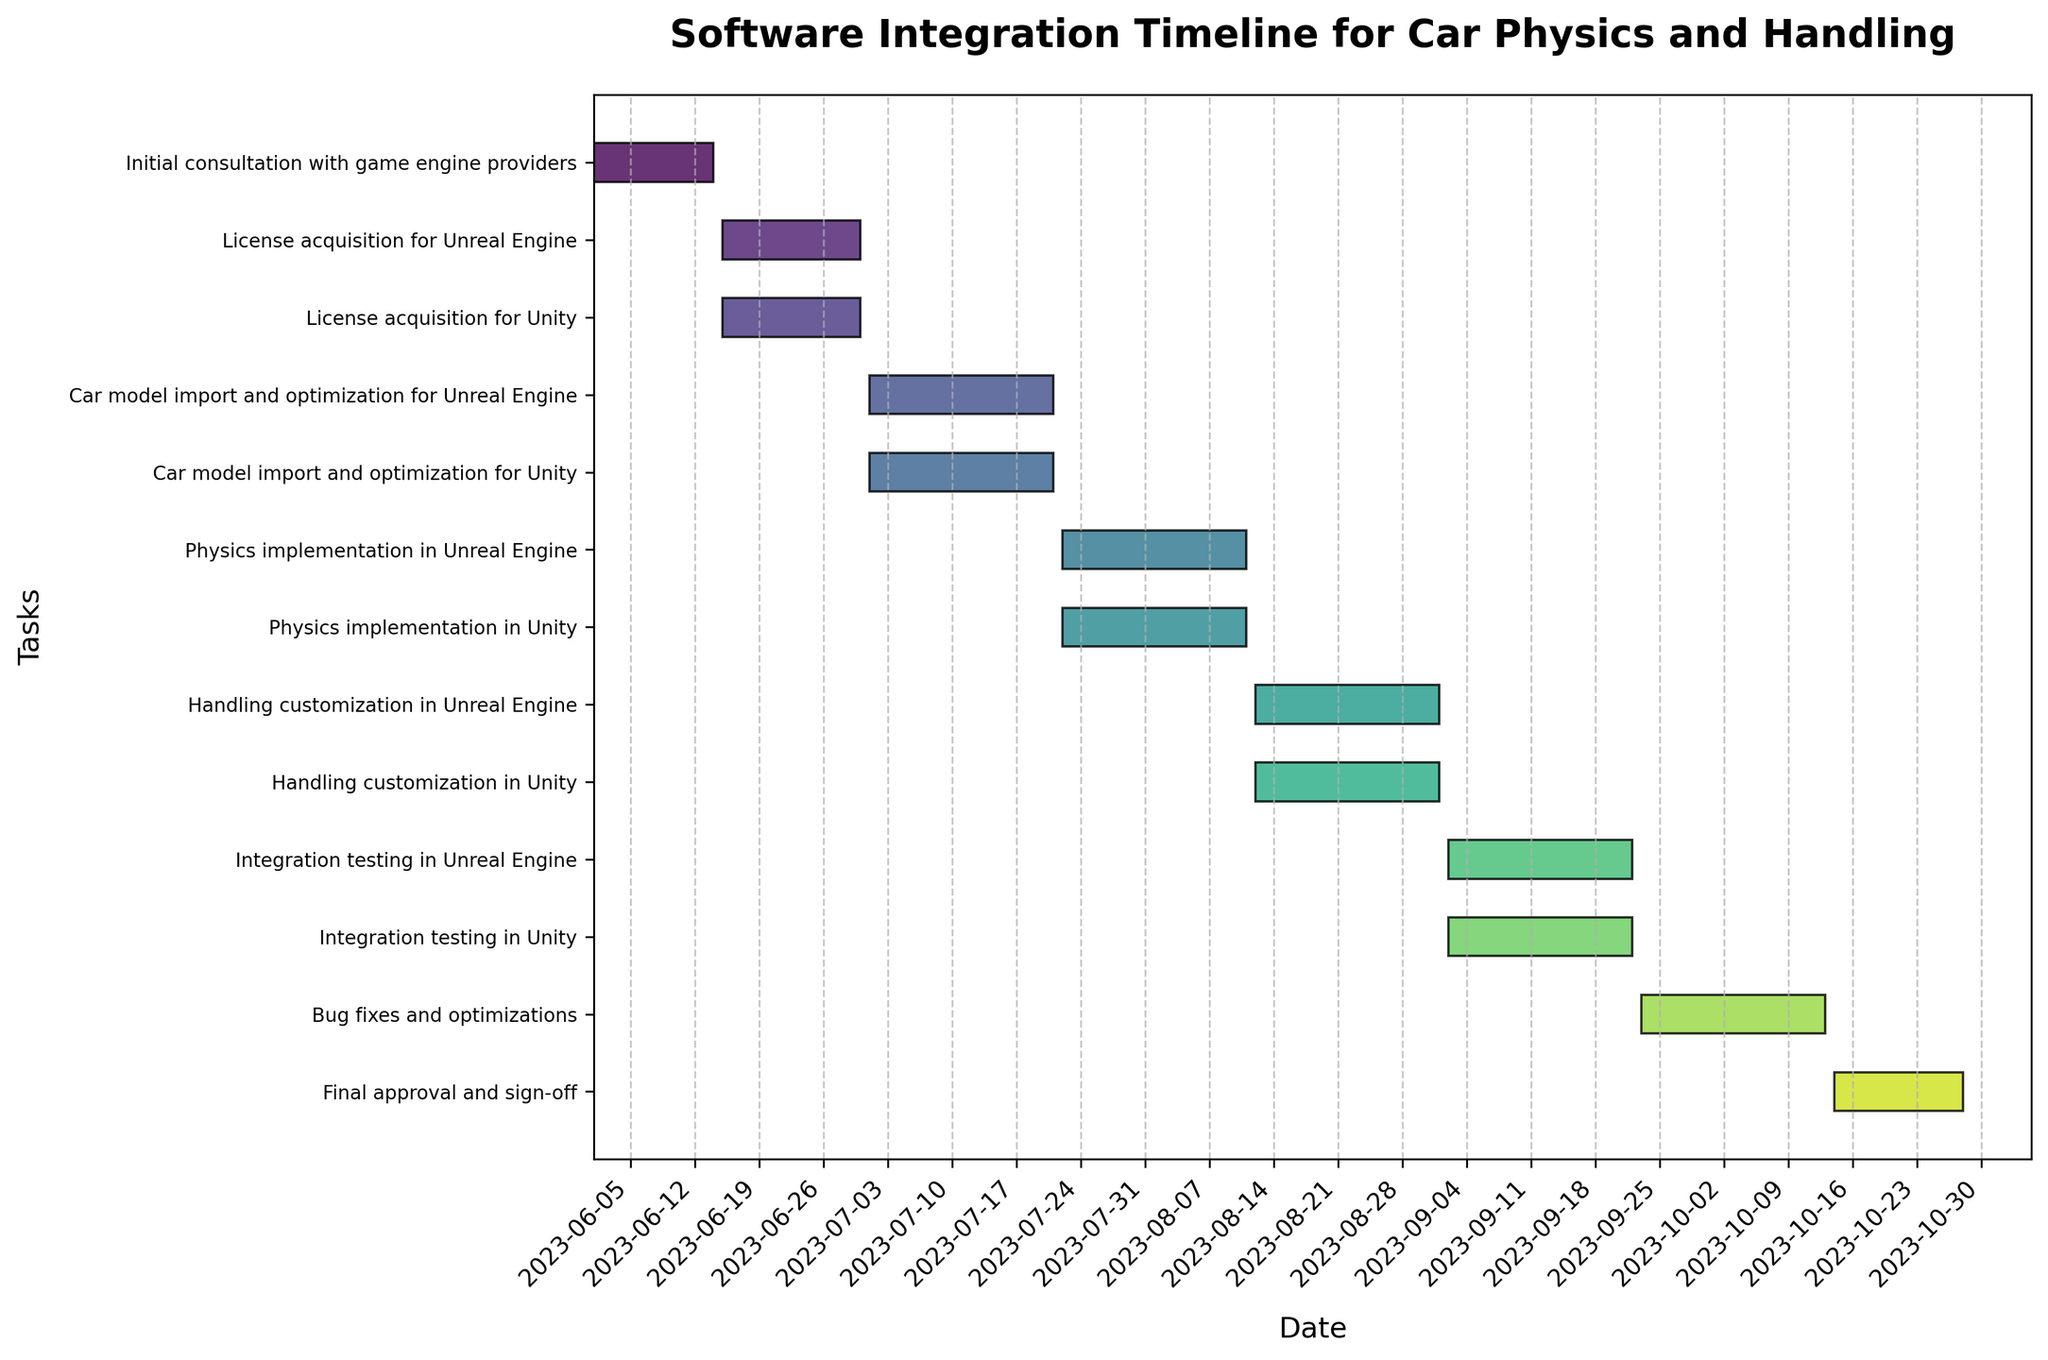What is the title of the Gantt Chart? The title is written at the top of the chart.
Answer: Software Integration Timeline for Car Physics and Handling How many tasks are displayed on the Gantt Chart? Count the number of unique tasks listed on the y-axis.
Answer: 12 When does the "Initial consultation with game engine providers" task start and end? Locate the "Initial consultation with game engine providers" task on the y-axis and read the start and end dates from the corresponding bar on the x-axis.
Answer: Starts on 2023-06-01 and ends on 2023-06-14 Which task has the longest duration? Compare the lengths of all the bars on the chart to determine the longest one.
Answer: Bug fixes and optimizations How many tasks are planned for Unity specifically? Count the number of tasks that include "Unity" in the task description.
Answer: 5 What is the duration of the "Integration testing in Unreal Engine" task? Measure the length of the "Integration testing in Unreal Engine" bar and count the number of days between the start and end date.
Answer: 21 days Do any tasks in the chart overlap in time? Observe the positions of the bars for each task along the x-axis to see if any bars overlap horizontally.
Answer: Yes Which task(s) immediately follow the "Car model import and optimization for Unity" task? Identify the end date of the "Car model import and optimization for Unity" task and find the task(s) that start on the next available date.
Answer: Physics implementation in Unity Are the start and end dates for the "License acquisition for Unreal Engine" and "License acquisition for Unity" the same? Compare the start and end dates of the two tasks listed in the chart.
Answer: Yes When is the final task, and how long does it last? Identify the last listed task in the chart and check its start and end dates to calculate the duration.
Answer: "Final approval and sign-off" from 2023-10-14 to 2023-10-28, lasting 14 days 